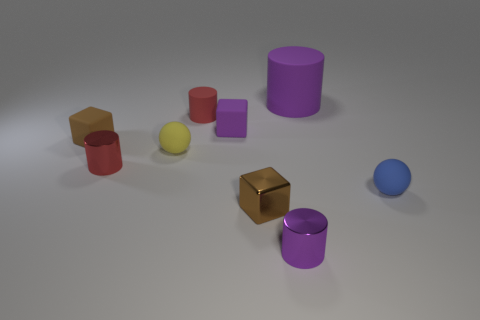What is the size of the blue thing?
Your response must be concise. Small. Is the size of the purple rubber block the same as the rubber sphere that is on the right side of the small purple metal object?
Ensure brevity in your answer.  Yes. There is a cylinder on the left side of the matte cylinder to the left of the rubber cylinder that is on the right side of the small brown metallic thing; what is its color?
Make the answer very short. Red. Does the tiny brown block on the left side of the brown metallic cube have the same material as the large purple thing?
Your answer should be compact. Yes. What number of other things are there of the same material as the large purple thing
Give a very brief answer. 5. There is a purple cylinder that is the same size as the brown metal thing; what is its material?
Make the answer very short. Metal. There is a tiny purple object in front of the red shiny object; is it the same shape as the small purple object that is left of the purple metallic thing?
Keep it short and to the point. No. There is a blue object that is the same size as the red metal cylinder; what is its shape?
Provide a short and direct response. Sphere. Is the purple cylinder behind the blue rubber ball made of the same material as the tiny red thing behind the red metal object?
Ensure brevity in your answer.  Yes. There is a small metallic thing behind the tiny blue matte sphere; are there any red cylinders that are right of it?
Offer a very short reply. Yes. 